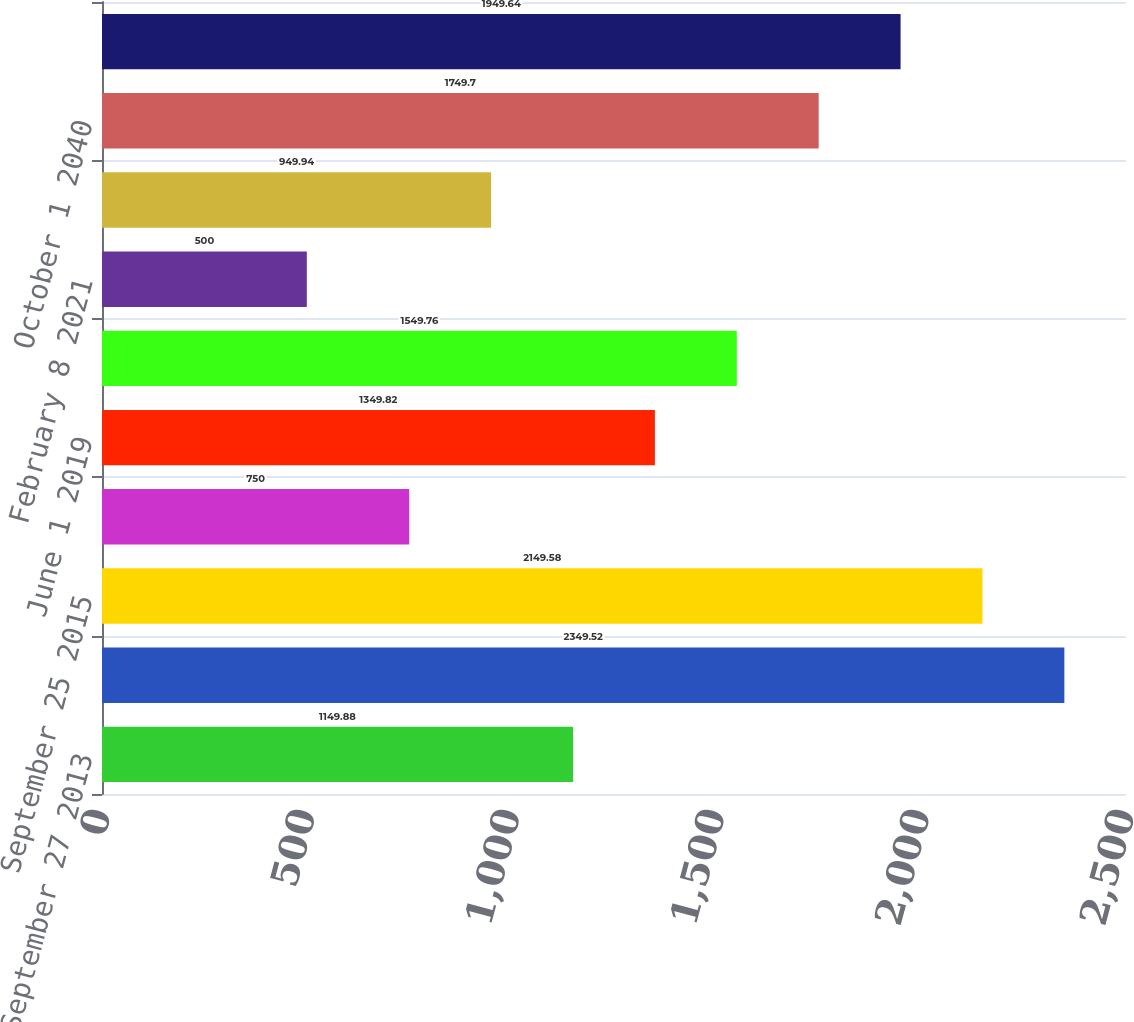Convert chart. <chart><loc_0><loc_0><loc_500><loc_500><bar_chart><fcel>September 27 2013<fcel>June 1 2014<fcel>September 25 2015<fcel>February 8 2016<fcel>June 1 2019<fcel>October 1 2020<fcel>February 8 2021<fcel>June 1 2039<fcel>October 1 2040<fcel>February 8 2041<nl><fcel>1149.88<fcel>2349.52<fcel>2149.58<fcel>750<fcel>1349.82<fcel>1549.76<fcel>500<fcel>949.94<fcel>1749.7<fcel>1949.64<nl></chart> 